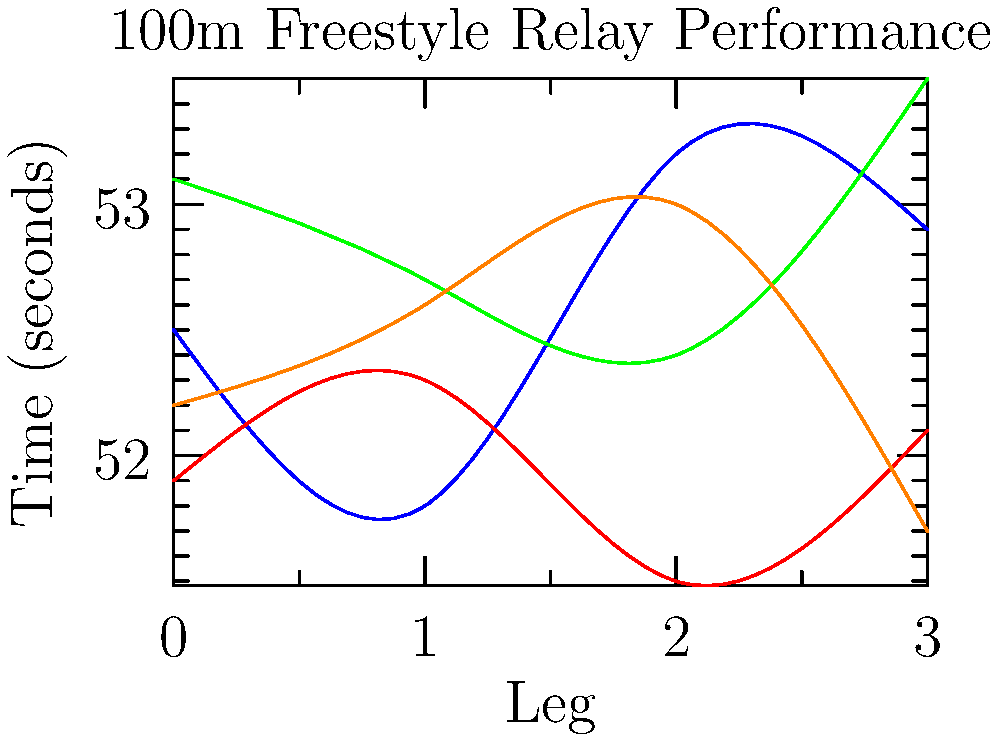Based on the performance chart of four swimmers (A, B, C, and D) for a 4x100m freestyle relay, what would be the optimal order to achieve the fastest overall time? To determine the optimal order for the relay team, we need to analyze each swimmer's performance across different legs of the race:

1. Swimmer A: Performs best in the second leg (51.8s)
2. Swimmer B: Performs best in the third leg (51.5s)
3. Swimmer C: Performs best in the third leg (52.4s)
4. Swimmer D: Performs best in the fourth leg (51.7s)

Step-by-step optimization:
1. Start with Swimmer B or C for the first leg, as they have the fastest times.
2. Place Swimmer A in the second leg, where they perform best.
3. Use the remaining swimmer between B and C for the third leg.
4. Finish with Swimmer D in the fourth leg, where they excel.

Comparing the options:
Option 1: B (51.9) - A (51.8) - C (52.4) - D (51.7) = 207.8s
Option 2: C (53.1) - A (51.8) - B (51.5) - D (51.7) = 208.1s

Therefore, the optimal order is B-A-C-D.
Answer: B-A-C-D 